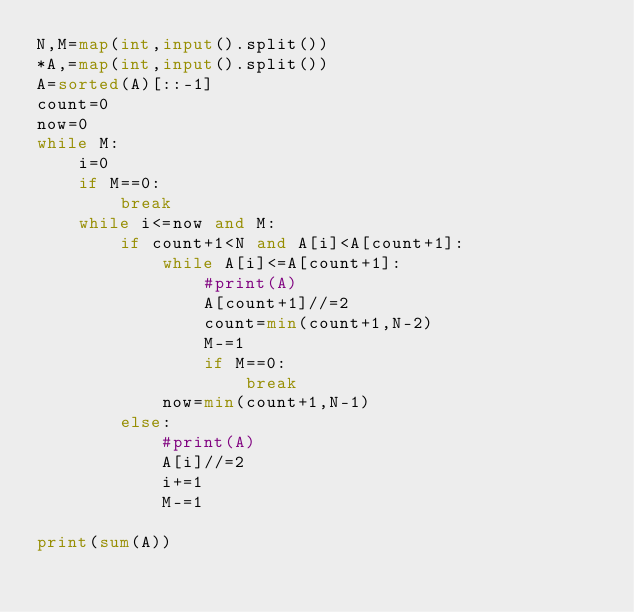Convert code to text. <code><loc_0><loc_0><loc_500><loc_500><_Python_>N,M=map(int,input().split())
*A,=map(int,input().split())
A=sorted(A)[::-1]
count=0
now=0
while M:
    i=0
    if M==0:
        break
    while i<=now and M:
        if count+1<N and A[i]<A[count+1]:
            while A[i]<=A[count+1]:
                #print(A)
                A[count+1]//=2
                count=min(count+1,N-2)
                M-=1
                if M==0:
                    break
            now=min(count+1,N-1)
        else:
            #print(A)
            A[i]//=2
            i+=1
            M-=1
        
print(sum(A))</code> 